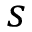<formula> <loc_0><loc_0><loc_500><loc_500>s</formula> 